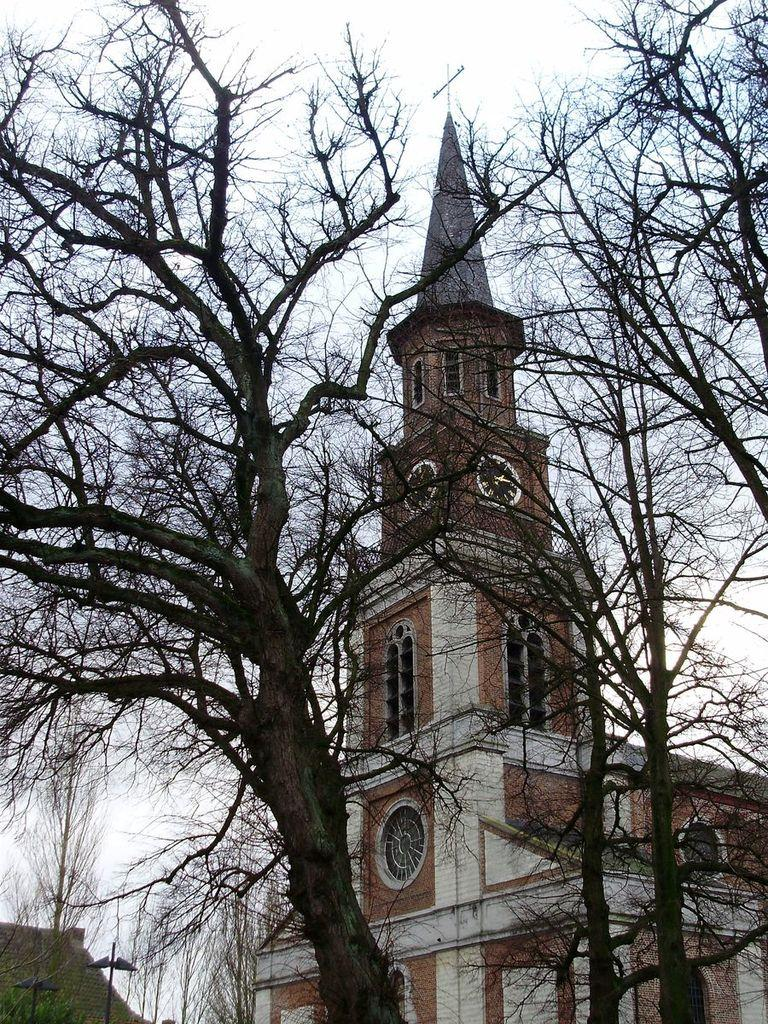What is the main structure visible in the image? There is a building in the image. What can be seen in front of the building? There are trees in front of the building in the image. What type of flowers are blooming in front of the building in the image? There are no flowers visible in the image; only trees are present in front of the building. 